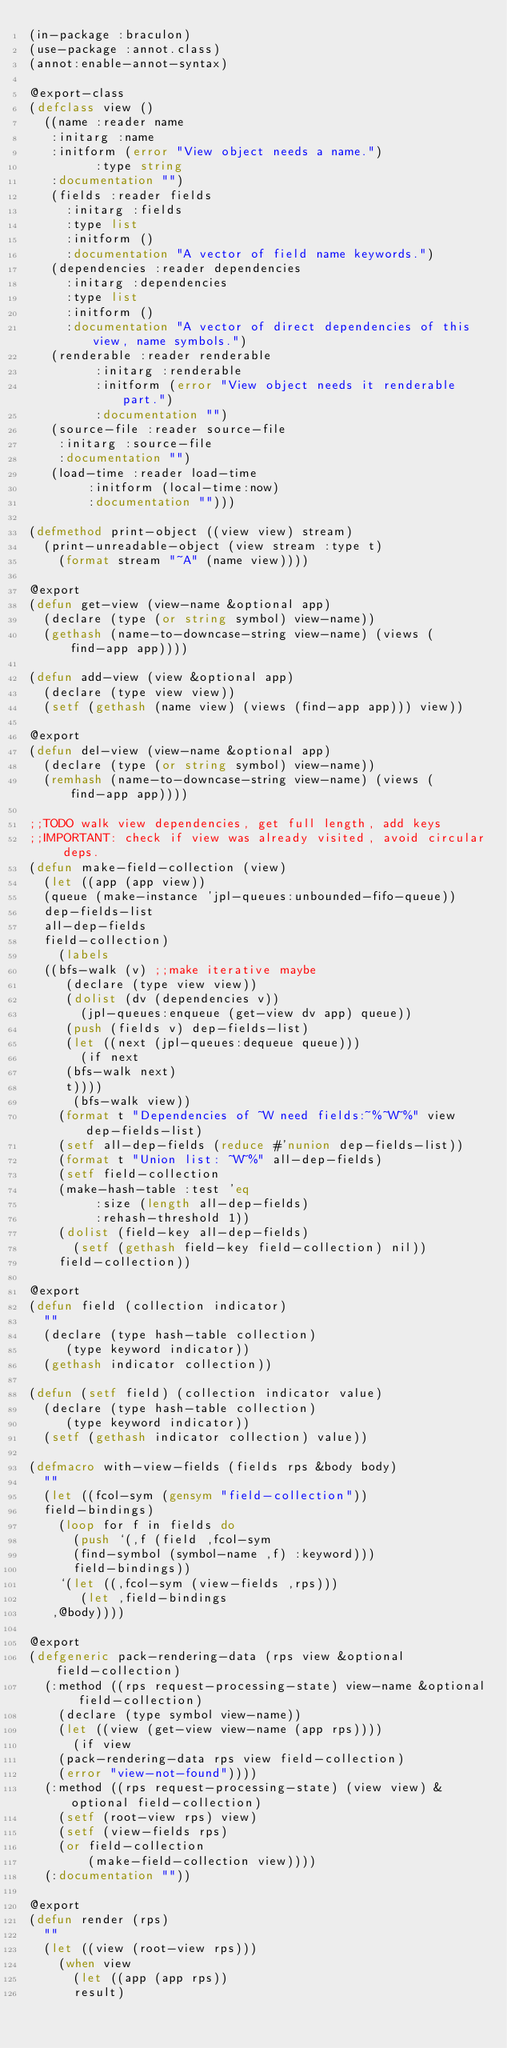Convert code to text. <code><loc_0><loc_0><loc_500><loc_500><_Lisp_>(in-package :braculon)
(use-package :annot.class)
(annot:enable-annot-syntax)

@export-class
(defclass view ()
  ((name :reader name
	 :initarg :name
	 :initform (error "View object needs a name.")
         :type string
	 :documentation "")
   (fields :reader fields
	   :initarg :fields
	   :type list
	   :initform ()
	   :documentation "A vector of field name keywords.")
   (dependencies :reader dependencies
		 :initarg :dependencies
		 :type list
		 :initform ()
		 :documentation "A vector of direct dependencies of this view, name symbols.")
   (renderable :reader renderable
	       :initarg :renderable
	       :initform (error "View object needs it renderable part.")
	       :documentation "")
   (source-file :reader source-file
		:initarg :source-file
		:documentation "")
   (load-time :reader load-time
	      :initform (local-time:now)
	      :documentation "")))

(defmethod print-object ((view view) stream)
  (print-unreadable-object (view stream :type t)
    (format stream "~A" (name view))))

@export
(defun get-view (view-name &optional app)
  (declare (type (or string symbol) view-name))
  (gethash (name-to-downcase-string view-name) (views (find-app app))))

(defun add-view (view &optional app)
  (declare (type view view))
  (setf (gethash (name view) (views (find-app app))) view))

@export
(defun del-view (view-name &optional app)
  (declare (type (or string symbol) view-name))
  (remhash (name-to-downcase-string view-name) (views (find-app app))))

;;TODO walk view dependencies, get full length, add keys
;;IMPORTANT: check if view was already visited, avoid circular deps.
(defun make-field-collection (view)
  (let ((app (app view))
	(queue (make-instance 'jpl-queues:unbounded-fifo-queue))
	dep-fields-list
	all-dep-fields
	field-collection)
    (labels
	((bfs-walk (v) ;;make iterative maybe
	   (declare (type view view))
	   (dolist (dv (dependencies v))
	     (jpl-queues:enqueue (get-view dv app) queue))
	   (push (fields v) dep-fields-list)
	   (let ((next (jpl-queues:dequeue queue)))
	     (if next
		 (bfs-walk next)
		 t))))
      (bfs-walk view))
    (format t "Dependencies of ~W need fields:~%~W~%" view dep-fields-list)
    (setf all-dep-fields (reduce #'nunion dep-fields-list))
    (format t "Union list: ~W~%" all-dep-fields)
    (setf field-collection
	  (make-hash-table :test 'eq
			   :size (length all-dep-fields)
			   :rehash-threshold 1))
    (dolist (field-key all-dep-fields)
      (setf (gethash field-key field-collection) nil))
    field-collection))

@export
(defun field (collection indicator)
  ""
  (declare (type hash-table collection)
	   (type keyword indicator))
  (gethash indicator collection))

(defun (setf field) (collection indicator value)
  (declare (type hash-table collection)
	   (type keyword indicator))
  (setf (gethash indicator collection) value))

(defmacro with-view-fields (fields rps &body body)
  ""
  (let ((fcol-sym (gensym "field-collection"))
	field-bindings)
    (loop for f in fields do
      (push `(,f (field ,fcol-sym
			(find-symbol (symbol-name ,f) :keyword)))
	    field-bindings))
    `(let ((,fcol-sym (view-fields ,rps)))
       (let ,field-bindings
	 ,@body))))

@export
(defgeneric pack-rendering-data (rps view &optional field-collection)
  (:method ((rps request-processing-state) view-name &optional field-collection)
    (declare (type symbol view-name))
    (let ((view (get-view view-name (app rps))))
      (if view
	  (pack-rendering-data rps view field-collection)
	  (error "view-not-found"))))
  (:method ((rps request-processing-state) (view view) &optional field-collection)
    (setf (root-view rps) view)
    (setf (view-fields rps)
	  (or field-collection
	      (make-field-collection view))))
  (:documentation ""))

@export
(defun render (rps)
  ""
  (let ((view (root-view rps)))
    (when view
      (let ((app (app rps))
	    result)</code> 